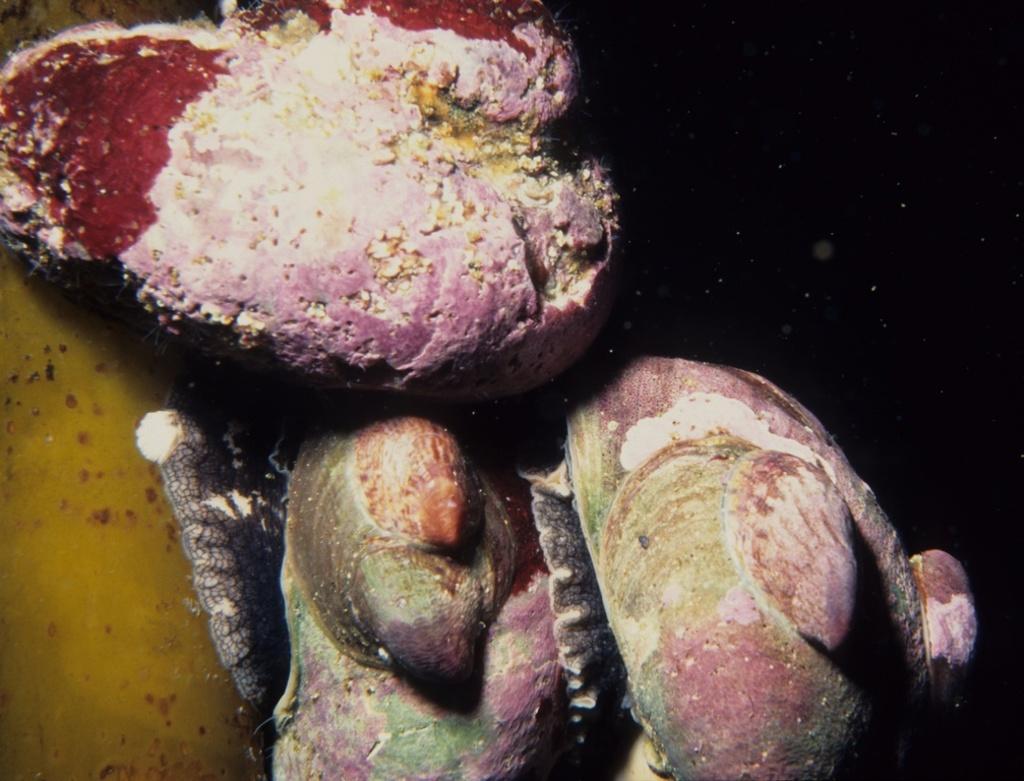Can you describe this image briefly? In this image there is a coral reef. 